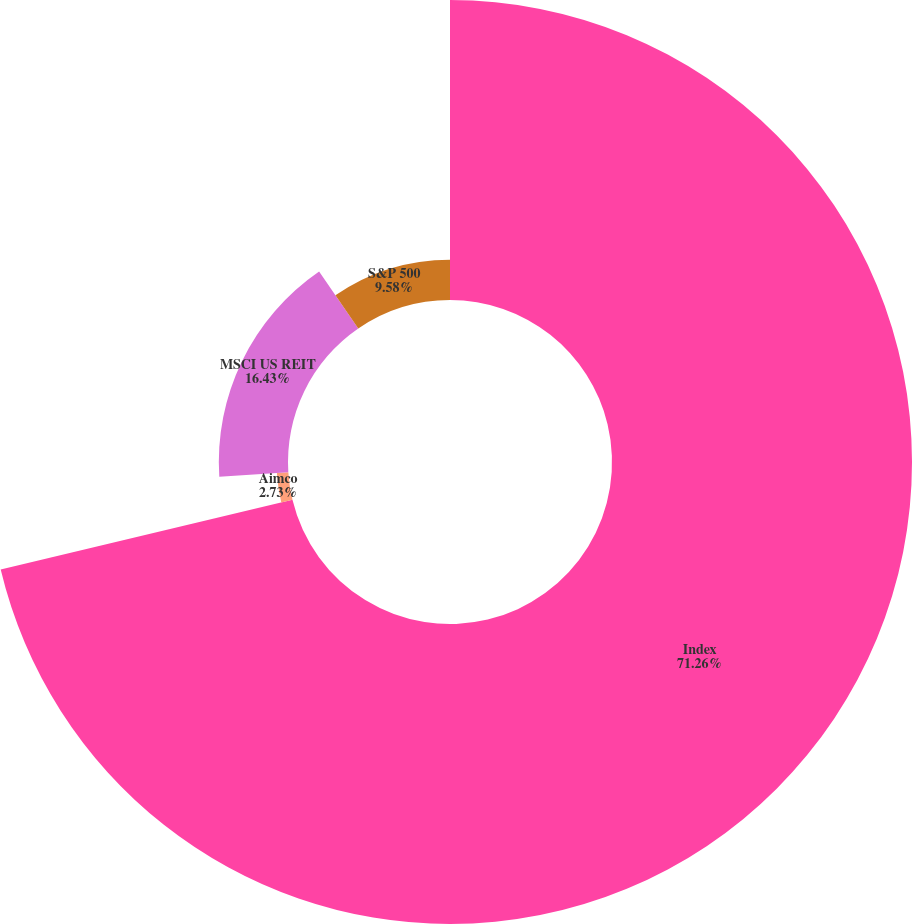Convert chart to OTSL. <chart><loc_0><loc_0><loc_500><loc_500><pie_chart><fcel>Index<fcel>Aimco<fcel>MSCI US REIT<fcel>S&P 500<nl><fcel>71.26%<fcel>2.73%<fcel>16.43%<fcel>9.58%<nl></chart> 